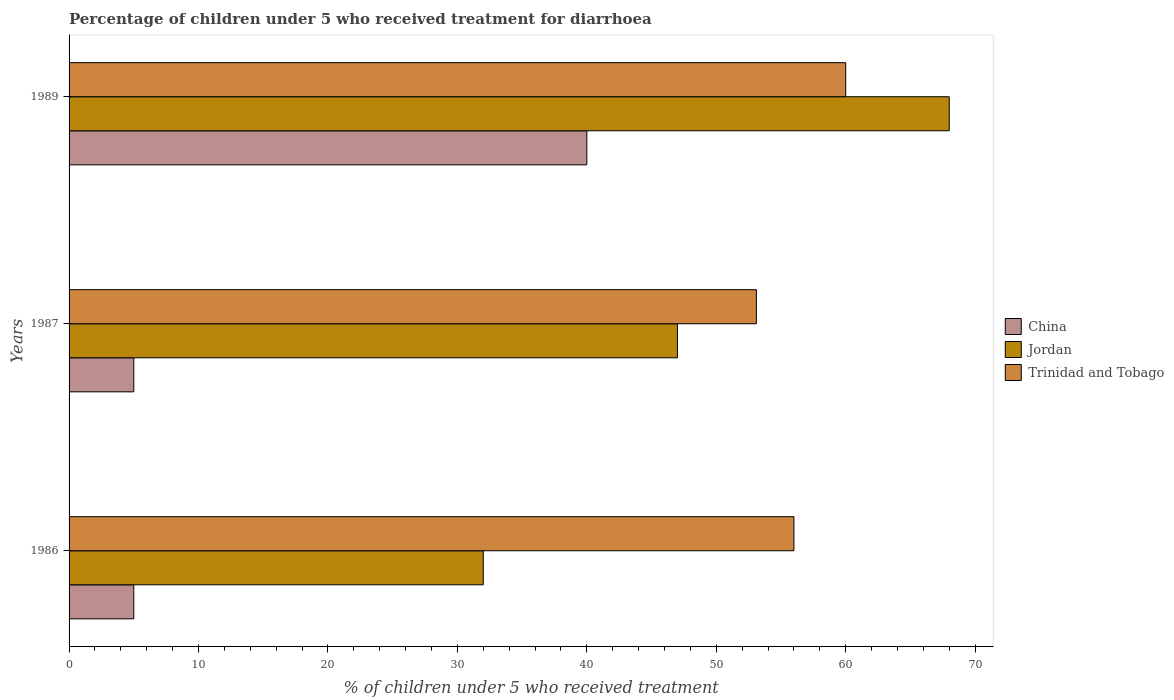How many different coloured bars are there?
Your answer should be very brief. 3. How many bars are there on the 2nd tick from the top?
Make the answer very short. 3. In how many cases, is the number of bars for a given year not equal to the number of legend labels?
Keep it short and to the point. 0. Across all years, what is the maximum percentage of children who received treatment for diarrhoea  in Trinidad and Tobago?
Provide a succinct answer. 60. Across all years, what is the minimum percentage of children who received treatment for diarrhoea  in Trinidad and Tobago?
Ensure brevity in your answer.  53.1. In which year was the percentage of children who received treatment for diarrhoea  in Jordan maximum?
Your response must be concise. 1989. In which year was the percentage of children who received treatment for diarrhoea  in China minimum?
Offer a very short reply. 1986. What is the total percentage of children who received treatment for diarrhoea  in Jordan in the graph?
Provide a succinct answer. 147. What is the difference between the percentage of children who received treatment for diarrhoea  in China in 1986 and that in 1987?
Your answer should be compact. 0. What is the difference between the percentage of children who received treatment for diarrhoea  in China in 1987 and the percentage of children who received treatment for diarrhoea  in Trinidad and Tobago in 1986?
Make the answer very short. -51. What is the average percentage of children who received treatment for diarrhoea  in Jordan per year?
Provide a succinct answer. 49. In how many years, is the percentage of children who received treatment for diarrhoea  in Trinidad and Tobago greater than 30 %?
Your answer should be very brief. 3. What is the ratio of the percentage of children who received treatment for diarrhoea  in Jordan in 1986 to that in 1989?
Ensure brevity in your answer.  0.47. Is the difference between the percentage of children who received treatment for diarrhoea  in Jordan in 1986 and 1989 greater than the difference between the percentage of children who received treatment for diarrhoea  in Trinidad and Tobago in 1986 and 1989?
Keep it short and to the point. No. What is the difference between the highest and the lowest percentage of children who received treatment for diarrhoea  in Trinidad and Tobago?
Provide a short and direct response. 6.9. In how many years, is the percentage of children who received treatment for diarrhoea  in China greater than the average percentage of children who received treatment for diarrhoea  in China taken over all years?
Give a very brief answer. 1. Is the sum of the percentage of children who received treatment for diarrhoea  in Trinidad and Tobago in 1986 and 1989 greater than the maximum percentage of children who received treatment for diarrhoea  in China across all years?
Ensure brevity in your answer.  Yes. What does the 2nd bar from the bottom in 1986 represents?
Offer a very short reply. Jordan. Is it the case that in every year, the sum of the percentage of children who received treatment for diarrhoea  in Jordan and percentage of children who received treatment for diarrhoea  in Trinidad and Tobago is greater than the percentage of children who received treatment for diarrhoea  in China?
Keep it short and to the point. Yes. How many years are there in the graph?
Your response must be concise. 3. Are the values on the major ticks of X-axis written in scientific E-notation?
Provide a short and direct response. No. Does the graph contain any zero values?
Offer a very short reply. No. What is the title of the graph?
Your answer should be very brief. Percentage of children under 5 who received treatment for diarrhoea. What is the label or title of the X-axis?
Your response must be concise. % of children under 5 who received treatment. What is the % of children under 5 who received treatment of Jordan in 1987?
Offer a terse response. 47. What is the % of children under 5 who received treatment of Trinidad and Tobago in 1987?
Your answer should be very brief. 53.1. What is the % of children under 5 who received treatment in China in 1989?
Give a very brief answer. 40. What is the % of children under 5 who received treatment in Jordan in 1989?
Your response must be concise. 68. What is the % of children under 5 who received treatment of Trinidad and Tobago in 1989?
Offer a very short reply. 60. Across all years, what is the maximum % of children under 5 who received treatment in Jordan?
Give a very brief answer. 68. Across all years, what is the maximum % of children under 5 who received treatment in Trinidad and Tobago?
Ensure brevity in your answer.  60. Across all years, what is the minimum % of children under 5 who received treatment of Jordan?
Give a very brief answer. 32. Across all years, what is the minimum % of children under 5 who received treatment in Trinidad and Tobago?
Your response must be concise. 53.1. What is the total % of children under 5 who received treatment of China in the graph?
Offer a very short reply. 50. What is the total % of children under 5 who received treatment of Jordan in the graph?
Your response must be concise. 147. What is the total % of children under 5 who received treatment in Trinidad and Tobago in the graph?
Ensure brevity in your answer.  169.1. What is the difference between the % of children under 5 who received treatment in China in 1986 and that in 1987?
Offer a terse response. 0. What is the difference between the % of children under 5 who received treatment of Trinidad and Tobago in 1986 and that in 1987?
Make the answer very short. 2.9. What is the difference between the % of children under 5 who received treatment of China in 1986 and that in 1989?
Your answer should be compact. -35. What is the difference between the % of children under 5 who received treatment of Jordan in 1986 and that in 1989?
Provide a short and direct response. -36. What is the difference between the % of children under 5 who received treatment in Trinidad and Tobago in 1986 and that in 1989?
Provide a succinct answer. -4. What is the difference between the % of children under 5 who received treatment of China in 1987 and that in 1989?
Your answer should be very brief. -35. What is the difference between the % of children under 5 who received treatment of Jordan in 1987 and that in 1989?
Offer a very short reply. -21. What is the difference between the % of children under 5 who received treatment of China in 1986 and the % of children under 5 who received treatment of Jordan in 1987?
Offer a terse response. -42. What is the difference between the % of children under 5 who received treatment in China in 1986 and the % of children under 5 who received treatment in Trinidad and Tobago in 1987?
Offer a very short reply. -48.1. What is the difference between the % of children under 5 who received treatment in Jordan in 1986 and the % of children under 5 who received treatment in Trinidad and Tobago in 1987?
Offer a terse response. -21.1. What is the difference between the % of children under 5 who received treatment of China in 1986 and the % of children under 5 who received treatment of Jordan in 1989?
Offer a terse response. -63. What is the difference between the % of children under 5 who received treatment in China in 1986 and the % of children under 5 who received treatment in Trinidad and Tobago in 1989?
Offer a terse response. -55. What is the difference between the % of children under 5 who received treatment in Jordan in 1986 and the % of children under 5 who received treatment in Trinidad and Tobago in 1989?
Make the answer very short. -28. What is the difference between the % of children under 5 who received treatment in China in 1987 and the % of children under 5 who received treatment in Jordan in 1989?
Offer a terse response. -63. What is the difference between the % of children under 5 who received treatment of China in 1987 and the % of children under 5 who received treatment of Trinidad and Tobago in 1989?
Offer a very short reply. -55. What is the difference between the % of children under 5 who received treatment in Jordan in 1987 and the % of children under 5 who received treatment in Trinidad and Tobago in 1989?
Make the answer very short. -13. What is the average % of children under 5 who received treatment of China per year?
Your answer should be compact. 16.67. What is the average % of children under 5 who received treatment of Trinidad and Tobago per year?
Offer a very short reply. 56.37. In the year 1986, what is the difference between the % of children under 5 who received treatment of China and % of children under 5 who received treatment of Jordan?
Ensure brevity in your answer.  -27. In the year 1986, what is the difference between the % of children under 5 who received treatment in China and % of children under 5 who received treatment in Trinidad and Tobago?
Your answer should be very brief. -51. In the year 1987, what is the difference between the % of children under 5 who received treatment of China and % of children under 5 who received treatment of Jordan?
Your response must be concise. -42. In the year 1987, what is the difference between the % of children under 5 who received treatment of China and % of children under 5 who received treatment of Trinidad and Tobago?
Ensure brevity in your answer.  -48.1. In the year 1987, what is the difference between the % of children under 5 who received treatment in Jordan and % of children under 5 who received treatment in Trinidad and Tobago?
Your answer should be compact. -6.1. In the year 1989, what is the difference between the % of children under 5 who received treatment of China and % of children under 5 who received treatment of Jordan?
Ensure brevity in your answer.  -28. In the year 1989, what is the difference between the % of children under 5 who received treatment in China and % of children under 5 who received treatment in Trinidad and Tobago?
Provide a short and direct response. -20. In the year 1989, what is the difference between the % of children under 5 who received treatment of Jordan and % of children under 5 who received treatment of Trinidad and Tobago?
Your answer should be compact. 8. What is the ratio of the % of children under 5 who received treatment in Jordan in 1986 to that in 1987?
Provide a succinct answer. 0.68. What is the ratio of the % of children under 5 who received treatment in Trinidad and Tobago in 1986 to that in 1987?
Keep it short and to the point. 1.05. What is the ratio of the % of children under 5 who received treatment of China in 1986 to that in 1989?
Offer a very short reply. 0.12. What is the ratio of the % of children under 5 who received treatment in Jordan in 1986 to that in 1989?
Offer a very short reply. 0.47. What is the ratio of the % of children under 5 who received treatment of Trinidad and Tobago in 1986 to that in 1989?
Provide a succinct answer. 0.93. What is the ratio of the % of children under 5 who received treatment in Jordan in 1987 to that in 1989?
Your answer should be very brief. 0.69. What is the ratio of the % of children under 5 who received treatment of Trinidad and Tobago in 1987 to that in 1989?
Your response must be concise. 0.89. What is the difference between the highest and the second highest % of children under 5 who received treatment of Jordan?
Provide a short and direct response. 21. What is the difference between the highest and the second highest % of children under 5 who received treatment of Trinidad and Tobago?
Provide a succinct answer. 4. 